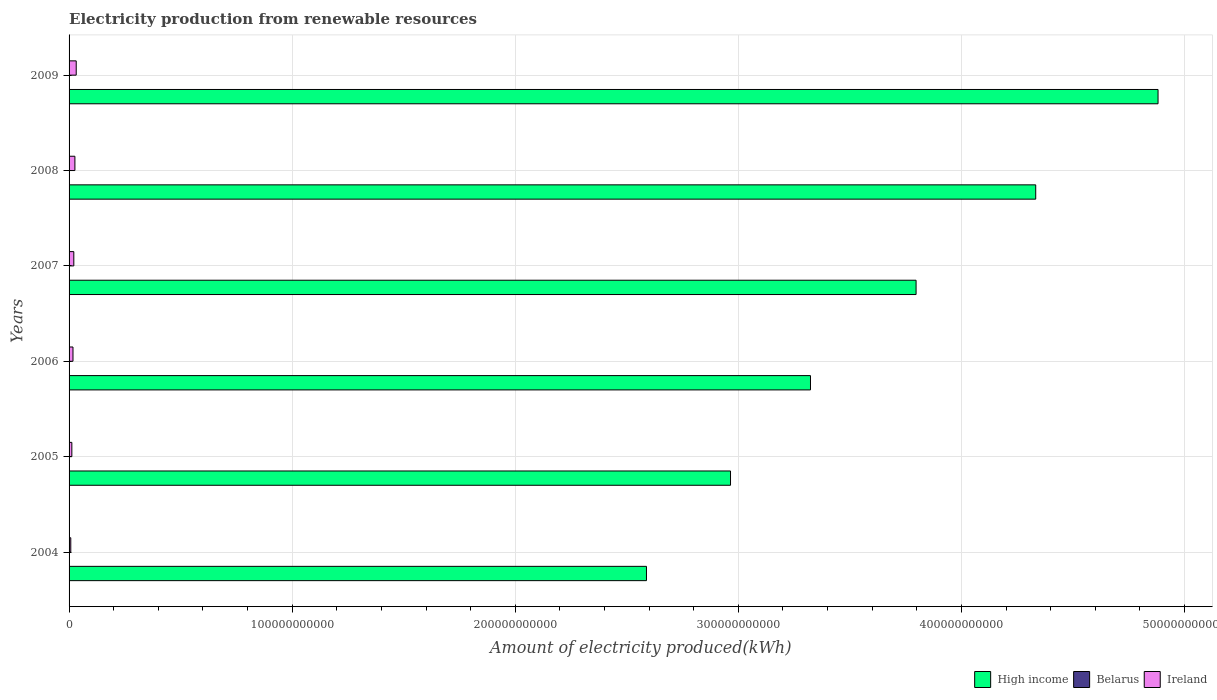How many groups of bars are there?
Your response must be concise. 6. Are the number of bars per tick equal to the number of legend labels?
Keep it short and to the point. Yes. What is the label of the 1st group of bars from the top?
Your answer should be very brief. 2009. What is the amount of electricity produced in High income in 2008?
Provide a succinct answer. 4.33e+11. Across all years, what is the maximum amount of electricity produced in High income?
Your response must be concise. 4.88e+11. Across all years, what is the minimum amount of electricity produced in Ireland?
Offer a terse response. 7.64e+08. What is the total amount of electricity produced in Belarus in the graph?
Your answer should be compact. 1.15e+08. What is the difference between the amount of electricity produced in High income in 2007 and that in 2008?
Make the answer very short. -5.36e+1. What is the difference between the amount of electricity produced in Ireland in 2009 and the amount of electricity produced in Belarus in 2008?
Make the answer very short. 3.17e+09. What is the average amount of electricity produced in Ireland per year?
Your answer should be compact. 1.95e+09. In the year 2005, what is the difference between the amount of electricity produced in Belarus and amount of electricity produced in Ireland?
Your answer should be very brief. -1.24e+09. In how many years, is the amount of electricity produced in Belarus greater than 300000000000 kWh?
Your response must be concise. 0. What is the ratio of the amount of electricity produced in Belarus in 2005 to that in 2006?
Ensure brevity in your answer.  0.33. Is the amount of electricity produced in Belarus in 2005 less than that in 2009?
Keep it short and to the point. Yes. Is the difference between the amount of electricity produced in Belarus in 2007 and 2009 greater than the difference between the amount of electricity produced in Ireland in 2007 and 2009?
Make the answer very short. Yes. What is the difference between the highest and the second highest amount of electricity produced in Belarus?
Your response must be concise. 2.70e+07. What is the difference between the highest and the lowest amount of electricity produced in Ireland?
Offer a very short reply. 2.44e+09. In how many years, is the amount of electricity produced in High income greater than the average amount of electricity produced in High income taken over all years?
Your response must be concise. 3. What does the 2nd bar from the top in 2008 represents?
Ensure brevity in your answer.  Belarus. What does the 2nd bar from the bottom in 2006 represents?
Your answer should be compact. Belarus. Are all the bars in the graph horizontal?
Your response must be concise. Yes. What is the difference between two consecutive major ticks on the X-axis?
Your answer should be very brief. 1.00e+11. Are the values on the major ticks of X-axis written in scientific E-notation?
Provide a succinct answer. No. Does the graph contain any zero values?
Your answer should be very brief. No. Does the graph contain grids?
Your response must be concise. Yes. Where does the legend appear in the graph?
Provide a short and direct response. Bottom right. How many legend labels are there?
Your response must be concise. 3. What is the title of the graph?
Provide a short and direct response. Electricity production from renewable resources. Does "Singapore" appear as one of the legend labels in the graph?
Ensure brevity in your answer.  No. What is the label or title of the X-axis?
Ensure brevity in your answer.  Amount of electricity produced(kWh). What is the Amount of electricity produced(kWh) in High income in 2004?
Your answer should be compact. 2.59e+11. What is the Amount of electricity produced(kWh) of Belarus in 2004?
Your answer should be very brief. 1.00e+06. What is the Amount of electricity produced(kWh) in Ireland in 2004?
Provide a short and direct response. 7.64e+08. What is the Amount of electricity produced(kWh) in High income in 2005?
Keep it short and to the point. 2.97e+11. What is the Amount of electricity produced(kWh) in Belarus in 2005?
Offer a terse response. 1.00e+06. What is the Amount of electricity produced(kWh) of Ireland in 2005?
Provide a short and direct response. 1.24e+09. What is the Amount of electricity produced(kWh) in High income in 2006?
Offer a terse response. 3.32e+11. What is the Amount of electricity produced(kWh) of Ireland in 2006?
Ensure brevity in your answer.  1.75e+09. What is the Amount of electricity produced(kWh) of High income in 2007?
Your answer should be compact. 3.80e+11. What is the Amount of electricity produced(kWh) of Belarus in 2007?
Provide a succinct answer. 1.50e+07. What is the Amount of electricity produced(kWh) of Ireland in 2007?
Offer a terse response. 2.13e+09. What is the Amount of electricity produced(kWh) of High income in 2008?
Offer a very short reply. 4.33e+11. What is the Amount of electricity produced(kWh) of Belarus in 2008?
Provide a short and direct response. 3.40e+07. What is the Amount of electricity produced(kWh) of Ireland in 2008?
Your response must be concise. 2.62e+09. What is the Amount of electricity produced(kWh) of High income in 2009?
Keep it short and to the point. 4.88e+11. What is the Amount of electricity produced(kWh) in Belarus in 2009?
Keep it short and to the point. 6.10e+07. What is the Amount of electricity produced(kWh) of Ireland in 2009?
Provide a short and direct response. 3.21e+09. Across all years, what is the maximum Amount of electricity produced(kWh) of High income?
Provide a short and direct response. 4.88e+11. Across all years, what is the maximum Amount of electricity produced(kWh) of Belarus?
Provide a short and direct response. 6.10e+07. Across all years, what is the maximum Amount of electricity produced(kWh) in Ireland?
Your answer should be very brief. 3.21e+09. Across all years, what is the minimum Amount of electricity produced(kWh) in High income?
Your answer should be very brief. 2.59e+11. Across all years, what is the minimum Amount of electricity produced(kWh) of Ireland?
Your answer should be compact. 7.64e+08. What is the total Amount of electricity produced(kWh) of High income in the graph?
Make the answer very short. 2.19e+12. What is the total Amount of electricity produced(kWh) of Belarus in the graph?
Offer a very short reply. 1.15e+08. What is the total Amount of electricity produced(kWh) in Ireland in the graph?
Offer a terse response. 1.17e+1. What is the difference between the Amount of electricity produced(kWh) of High income in 2004 and that in 2005?
Your answer should be very brief. -3.77e+1. What is the difference between the Amount of electricity produced(kWh) of Ireland in 2004 and that in 2005?
Offer a terse response. -4.78e+08. What is the difference between the Amount of electricity produced(kWh) in High income in 2004 and that in 2006?
Provide a short and direct response. -7.35e+1. What is the difference between the Amount of electricity produced(kWh) of Belarus in 2004 and that in 2006?
Provide a short and direct response. -2.00e+06. What is the difference between the Amount of electricity produced(kWh) of Ireland in 2004 and that in 2006?
Provide a short and direct response. -9.87e+08. What is the difference between the Amount of electricity produced(kWh) of High income in 2004 and that in 2007?
Offer a terse response. -1.21e+11. What is the difference between the Amount of electricity produced(kWh) of Belarus in 2004 and that in 2007?
Your response must be concise. -1.40e+07. What is the difference between the Amount of electricity produced(kWh) of Ireland in 2004 and that in 2007?
Provide a succinct answer. -1.36e+09. What is the difference between the Amount of electricity produced(kWh) in High income in 2004 and that in 2008?
Provide a succinct answer. -1.74e+11. What is the difference between the Amount of electricity produced(kWh) in Belarus in 2004 and that in 2008?
Ensure brevity in your answer.  -3.30e+07. What is the difference between the Amount of electricity produced(kWh) in Ireland in 2004 and that in 2008?
Make the answer very short. -1.86e+09. What is the difference between the Amount of electricity produced(kWh) in High income in 2004 and that in 2009?
Your answer should be compact. -2.29e+11. What is the difference between the Amount of electricity produced(kWh) of Belarus in 2004 and that in 2009?
Provide a short and direct response. -6.00e+07. What is the difference between the Amount of electricity produced(kWh) of Ireland in 2004 and that in 2009?
Make the answer very short. -2.44e+09. What is the difference between the Amount of electricity produced(kWh) in High income in 2005 and that in 2006?
Offer a terse response. -3.59e+1. What is the difference between the Amount of electricity produced(kWh) of Belarus in 2005 and that in 2006?
Offer a very short reply. -2.00e+06. What is the difference between the Amount of electricity produced(kWh) of Ireland in 2005 and that in 2006?
Keep it short and to the point. -5.09e+08. What is the difference between the Amount of electricity produced(kWh) of High income in 2005 and that in 2007?
Keep it short and to the point. -8.32e+1. What is the difference between the Amount of electricity produced(kWh) in Belarus in 2005 and that in 2007?
Offer a very short reply. -1.40e+07. What is the difference between the Amount of electricity produced(kWh) of Ireland in 2005 and that in 2007?
Ensure brevity in your answer.  -8.85e+08. What is the difference between the Amount of electricity produced(kWh) of High income in 2005 and that in 2008?
Your response must be concise. -1.37e+11. What is the difference between the Amount of electricity produced(kWh) in Belarus in 2005 and that in 2008?
Keep it short and to the point. -3.30e+07. What is the difference between the Amount of electricity produced(kWh) in Ireland in 2005 and that in 2008?
Ensure brevity in your answer.  -1.38e+09. What is the difference between the Amount of electricity produced(kWh) of High income in 2005 and that in 2009?
Offer a terse response. -1.92e+11. What is the difference between the Amount of electricity produced(kWh) in Belarus in 2005 and that in 2009?
Give a very brief answer. -6.00e+07. What is the difference between the Amount of electricity produced(kWh) of Ireland in 2005 and that in 2009?
Your answer should be very brief. -1.96e+09. What is the difference between the Amount of electricity produced(kWh) of High income in 2006 and that in 2007?
Keep it short and to the point. -4.73e+1. What is the difference between the Amount of electricity produced(kWh) in Belarus in 2006 and that in 2007?
Provide a short and direct response. -1.20e+07. What is the difference between the Amount of electricity produced(kWh) in Ireland in 2006 and that in 2007?
Make the answer very short. -3.76e+08. What is the difference between the Amount of electricity produced(kWh) in High income in 2006 and that in 2008?
Provide a succinct answer. -1.01e+11. What is the difference between the Amount of electricity produced(kWh) in Belarus in 2006 and that in 2008?
Provide a succinct answer. -3.10e+07. What is the difference between the Amount of electricity produced(kWh) in Ireland in 2006 and that in 2008?
Provide a succinct answer. -8.68e+08. What is the difference between the Amount of electricity produced(kWh) of High income in 2006 and that in 2009?
Your answer should be very brief. -1.56e+11. What is the difference between the Amount of electricity produced(kWh) of Belarus in 2006 and that in 2009?
Keep it short and to the point. -5.80e+07. What is the difference between the Amount of electricity produced(kWh) in Ireland in 2006 and that in 2009?
Provide a short and direct response. -1.46e+09. What is the difference between the Amount of electricity produced(kWh) of High income in 2007 and that in 2008?
Your answer should be compact. -5.36e+1. What is the difference between the Amount of electricity produced(kWh) of Belarus in 2007 and that in 2008?
Offer a terse response. -1.90e+07. What is the difference between the Amount of electricity produced(kWh) in Ireland in 2007 and that in 2008?
Provide a succinct answer. -4.92e+08. What is the difference between the Amount of electricity produced(kWh) in High income in 2007 and that in 2009?
Offer a very short reply. -1.08e+11. What is the difference between the Amount of electricity produced(kWh) in Belarus in 2007 and that in 2009?
Your answer should be compact. -4.60e+07. What is the difference between the Amount of electricity produced(kWh) in Ireland in 2007 and that in 2009?
Your answer should be very brief. -1.08e+09. What is the difference between the Amount of electricity produced(kWh) in High income in 2008 and that in 2009?
Your answer should be compact. -5.48e+1. What is the difference between the Amount of electricity produced(kWh) in Belarus in 2008 and that in 2009?
Your answer should be very brief. -2.70e+07. What is the difference between the Amount of electricity produced(kWh) in Ireland in 2008 and that in 2009?
Give a very brief answer. -5.87e+08. What is the difference between the Amount of electricity produced(kWh) of High income in 2004 and the Amount of electricity produced(kWh) of Belarus in 2005?
Make the answer very short. 2.59e+11. What is the difference between the Amount of electricity produced(kWh) of High income in 2004 and the Amount of electricity produced(kWh) of Ireland in 2005?
Ensure brevity in your answer.  2.58e+11. What is the difference between the Amount of electricity produced(kWh) of Belarus in 2004 and the Amount of electricity produced(kWh) of Ireland in 2005?
Make the answer very short. -1.24e+09. What is the difference between the Amount of electricity produced(kWh) in High income in 2004 and the Amount of electricity produced(kWh) in Belarus in 2006?
Provide a short and direct response. 2.59e+11. What is the difference between the Amount of electricity produced(kWh) in High income in 2004 and the Amount of electricity produced(kWh) in Ireland in 2006?
Provide a succinct answer. 2.57e+11. What is the difference between the Amount of electricity produced(kWh) of Belarus in 2004 and the Amount of electricity produced(kWh) of Ireland in 2006?
Offer a very short reply. -1.75e+09. What is the difference between the Amount of electricity produced(kWh) of High income in 2004 and the Amount of electricity produced(kWh) of Belarus in 2007?
Provide a short and direct response. 2.59e+11. What is the difference between the Amount of electricity produced(kWh) of High income in 2004 and the Amount of electricity produced(kWh) of Ireland in 2007?
Ensure brevity in your answer.  2.57e+11. What is the difference between the Amount of electricity produced(kWh) in Belarus in 2004 and the Amount of electricity produced(kWh) in Ireland in 2007?
Your response must be concise. -2.13e+09. What is the difference between the Amount of electricity produced(kWh) of High income in 2004 and the Amount of electricity produced(kWh) of Belarus in 2008?
Provide a short and direct response. 2.59e+11. What is the difference between the Amount of electricity produced(kWh) of High income in 2004 and the Amount of electricity produced(kWh) of Ireland in 2008?
Give a very brief answer. 2.56e+11. What is the difference between the Amount of electricity produced(kWh) in Belarus in 2004 and the Amount of electricity produced(kWh) in Ireland in 2008?
Provide a succinct answer. -2.62e+09. What is the difference between the Amount of electricity produced(kWh) in High income in 2004 and the Amount of electricity produced(kWh) in Belarus in 2009?
Keep it short and to the point. 2.59e+11. What is the difference between the Amount of electricity produced(kWh) in High income in 2004 and the Amount of electricity produced(kWh) in Ireland in 2009?
Give a very brief answer. 2.56e+11. What is the difference between the Amount of electricity produced(kWh) in Belarus in 2004 and the Amount of electricity produced(kWh) in Ireland in 2009?
Provide a short and direct response. -3.20e+09. What is the difference between the Amount of electricity produced(kWh) of High income in 2005 and the Amount of electricity produced(kWh) of Belarus in 2006?
Your answer should be very brief. 2.97e+11. What is the difference between the Amount of electricity produced(kWh) of High income in 2005 and the Amount of electricity produced(kWh) of Ireland in 2006?
Your response must be concise. 2.95e+11. What is the difference between the Amount of electricity produced(kWh) in Belarus in 2005 and the Amount of electricity produced(kWh) in Ireland in 2006?
Give a very brief answer. -1.75e+09. What is the difference between the Amount of electricity produced(kWh) of High income in 2005 and the Amount of electricity produced(kWh) of Belarus in 2007?
Keep it short and to the point. 2.96e+11. What is the difference between the Amount of electricity produced(kWh) in High income in 2005 and the Amount of electricity produced(kWh) in Ireland in 2007?
Your answer should be very brief. 2.94e+11. What is the difference between the Amount of electricity produced(kWh) of Belarus in 2005 and the Amount of electricity produced(kWh) of Ireland in 2007?
Offer a terse response. -2.13e+09. What is the difference between the Amount of electricity produced(kWh) in High income in 2005 and the Amount of electricity produced(kWh) in Belarus in 2008?
Your response must be concise. 2.96e+11. What is the difference between the Amount of electricity produced(kWh) of High income in 2005 and the Amount of electricity produced(kWh) of Ireland in 2008?
Your answer should be compact. 2.94e+11. What is the difference between the Amount of electricity produced(kWh) in Belarus in 2005 and the Amount of electricity produced(kWh) in Ireland in 2008?
Make the answer very short. -2.62e+09. What is the difference between the Amount of electricity produced(kWh) in High income in 2005 and the Amount of electricity produced(kWh) in Belarus in 2009?
Provide a succinct answer. 2.96e+11. What is the difference between the Amount of electricity produced(kWh) in High income in 2005 and the Amount of electricity produced(kWh) in Ireland in 2009?
Keep it short and to the point. 2.93e+11. What is the difference between the Amount of electricity produced(kWh) in Belarus in 2005 and the Amount of electricity produced(kWh) in Ireland in 2009?
Provide a succinct answer. -3.20e+09. What is the difference between the Amount of electricity produced(kWh) in High income in 2006 and the Amount of electricity produced(kWh) in Belarus in 2007?
Provide a short and direct response. 3.32e+11. What is the difference between the Amount of electricity produced(kWh) of High income in 2006 and the Amount of electricity produced(kWh) of Ireland in 2007?
Your response must be concise. 3.30e+11. What is the difference between the Amount of electricity produced(kWh) in Belarus in 2006 and the Amount of electricity produced(kWh) in Ireland in 2007?
Your answer should be compact. -2.12e+09. What is the difference between the Amount of electricity produced(kWh) of High income in 2006 and the Amount of electricity produced(kWh) of Belarus in 2008?
Ensure brevity in your answer.  3.32e+11. What is the difference between the Amount of electricity produced(kWh) of High income in 2006 and the Amount of electricity produced(kWh) of Ireland in 2008?
Give a very brief answer. 3.30e+11. What is the difference between the Amount of electricity produced(kWh) in Belarus in 2006 and the Amount of electricity produced(kWh) in Ireland in 2008?
Provide a short and direct response. -2.62e+09. What is the difference between the Amount of electricity produced(kWh) in High income in 2006 and the Amount of electricity produced(kWh) in Belarus in 2009?
Provide a short and direct response. 3.32e+11. What is the difference between the Amount of electricity produced(kWh) of High income in 2006 and the Amount of electricity produced(kWh) of Ireland in 2009?
Your response must be concise. 3.29e+11. What is the difference between the Amount of electricity produced(kWh) of Belarus in 2006 and the Amount of electricity produced(kWh) of Ireland in 2009?
Your answer should be very brief. -3.20e+09. What is the difference between the Amount of electricity produced(kWh) of High income in 2007 and the Amount of electricity produced(kWh) of Belarus in 2008?
Your answer should be compact. 3.80e+11. What is the difference between the Amount of electricity produced(kWh) in High income in 2007 and the Amount of electricity produced(kWh) in Ireland in 2008?
Your answer should be very brief. 3.77e+11. What is the difference between the Amount of electricity produced(kWh) in Belarus in 2007 and the Amount of electricity produced(kWh) in Ireland in 2008?
Your answer should be very brief. -2.60e+09. What is the difference between the Amount of electricity produced(kWh) of High income in 2007 and the Amount of electricity produced(kWh) of Belarus in 2009?
Your response must be concise. 3.80e+11. What is the difference between the Amount of electricity produced(kWh) in High income in 2007 and the Amount of electricity produced(kWh) in Ireland in 2009?
Your answer should be very brief. 3.76e+11. What is the difference between the Amount of electricity produced(kWh) of Belarus in 2007 and the Amount of electricity produced(kWh) of Ireland in 2009?
Offer a very short reply. -3.19e+09. What is the difference between the Amount of electricity produced(kWh) in High income in 2008 and the Amount of electricity produced(kWh) in Belarus in 2009?
Give a very brief answer. 4.33e+11. What is the difference between the Amount of electricity produced(kWh) of High income in 2008 and the Amount of electricity produced(kWh) of Ireland in 2009?
Make the answer very short. 4.30e+11. What is the difference between the Amount of electricity produced(kWh) in Belarus in 2008 and the Amount of electricity produced(kWh) in Ireland in 2009?
Make the answer very short. -3.17e+09. What is the average Amount of electricity produced(kWh) of High income per year?
Provide a short and direct response. 3.65e+11. What is the average Amount of electricity produced(kWh) of Belarus per year?
Your response must be concise. 1.92e+07. What is the average Amount of electricity produced(kWh) of Ireland per year?
Your answer should be very brief. 1.95e+09. In the year 2004, what is the difference between the Amount of electricity produced(kWh) in High income and Amount of electricity produced(kWh) in Belarus?
Your answer should be compact. 2.59e+11. In the year 2004, what is the difference between the Amount of electricity produced(kWh) of High income and Amount of electricity produced(kWh) of Ireland?
Your answer should be compact. 2.58e+11. In the year 2004, what is the difference between the Amount of electricity produced(kWh) in Belarus and Amount of electricity produced(kWh) in Ireland?
Give a very brief answer. -7.63e+08. In the year 2005, what is the difference between the Amount of electricity produced(kWh) of High income and Amount of electricity produced(kWh) of Belarus?
Offer a very short reply. 2.97e+11. In the year 2005, what is the difference between the Amount of electricity produced(kWh) in High income and Amount of electricity produced(kWh) in Ireland?
Make the answer very short. 2.95e+11. In the year 2005, what is the difference between the Amount of electricity produced(kWh) in Belarus and Amount of electricity produced(kWh) in Ireland?
Make the answer very short. -1.24e+09. In the year 2006, what is the difference between the Amount of electricity produced(kWh) in High income and Amount of electricity produced(kWh) in Belarus?
Offer a very short reply. 3.32e+11. In the year 2006, what is the difference between the Amount of electricity produced(kWh) in High income and Amount of electricity produced(kWh) in Ireland?
Provide a succinct answer. 3.31e+11. In the year 2006, what is the difference between the Amount of electricity produced(kWh) in Belarus and Amount of electricity produced(kWh) in Ireland?
Provide a succinct answer. -1.75e+09. In the year 2007, what is the difference between the Amount of electricity produced(kWh) of High income and Amount of electricity produced(kWh) of Belarus?
Provide a succinct answer. 3.80e+11. In the year 2007, what is the difference between the Amount of electricity produced(kWh) in High income and Amount of electricity produced(kWh) in Ireland?
Your answer should be very brief. 3.78e+11. In the year 2007, what is the difference between the Amount of electricity produced(kWh) in Belarus and Amount of electricity produced(kWh) in Ireland?
Keep it short and to the point. -2.11e+09. In the year 2008, what is the difference between the Amount of electricity produced(kWh) of High income and Amount of electricity produced(kWh) of Belarus?
Keep it short and to the point. 4.33e+11. In the year 2008, what is the difference between the Amount of electricity produced(kWh) of High income and Amount of electricity produced(kWh) of Ireland?
Offer a very short reply. 4.31e+11. In the year 2008, what is the difference between the Amount of electricity produced(kWh) of Belarus and Amount of electricity produced(kWh) of Ireland?
Provide a succinct answer. -2.58e+09. In the year 2009, what is the difference between the Amount of electricity produced(kWh) in High income and Amount of electricity produced(kWh) in Belarus?
Your answer should be compact. 4.88e+11. In the year 2009, what is the difference between the Amount of electricity produced(kWh) of High income and Amount of electricity produced(kWh) of Ireland?
Ensure brevity in your answer.  4.85e+11. In the year 2009, what is the difference between the Amount of electricity produced(kWh) of Belarus and Amount of electricity produced(kWh) of Ireland?
Provide a succinct answer. -3.14e+09. What is the ratio of the Amount of electricity produced(kWh) in High income in 2004 to that in 2005?
Provide a short and direct response. 0.87. What is the ratio of the Amount of electricity produced(kWh) of Belarus in 2004 to that in 2005?
Give a very brief answer. 1. What is the ratio of the Amount of electricity produced(kWh) in Ireland in 2004 to that in 2005?
Give a very brief answer. 0.62. What is the ratio of the Amount of electricity produced(kWh) of High income in 2004 to that in 2006?
Offer a very short reply. 0.78. What is the ratio of the Amount of electricity produced(kWh) in Ireland in 2004 to that in 2006?
Your response must be concise. 0.44. What is the ratio of the Amount of electricity produced(kWh) in High income in 2004 to that in 2007?
Offer a terse response. 0.68. What is the ratio of the Amount of electricity produced(kWh) of Belarus in 2004 to that in 2007?
Provide a succinct answer. 0.07. What is the ratio of the Amount of electricity produced(kWh) in Ireland in 2004 to that in 2007?
Provide a short and direct response. 0.36. What is the ratio of the Amount of electricity produced(kWh) in High income in 2004 to that in 2008?
Give a very brief answer. 0.6. What is the ratio of the Amount of electricity produced(kWh) of Belarus in 2004 to that in 2008?
Ensure brevity in your answer.  0.03. What is the ratio of the Amount of electricity produced(kWh) in Ireland in 2004 to that in 2008?
Make the answer very short. 0.29. What is the ratio of the Amount of electricity produced(kWh) in High income in 2004 to that in 2009?
Give a very brief answer. 0.53. What is the ratio of the Amount of electricity produced(kWh) of Belarus in 2004 to that in 2009?
Provide a succinct answer. 0.02. What is the ratio of the Amount of electricity produced(kWh) of Ireland in 2004 to that in 2009?
Offer a terse response. 0.24. What is the ratio of the Amount of electricity produced(kWh) in High income in 2005 to that in 2006?
Your answer should be compact. 0.89. What is the ratio of the Amount of electricity produced(kWh) in Belarus in 2005 to that in 2006?
Offer a very short reply. 0.33. What is the ratio of the Amount of electricity produced(kWh) of Ireland in 2005 to that in 2006?
Offer a very short reply. 0.71. What is the ratio of the Amount of electricity produced(kWh) in High income in 2005 to that in 2007?
Provide a short and direct response. 0.78. What is the ratio of the Amount of electricity produced(kWh) of Belarus in 2005 to that in 2007?
Ensure brevity in your answer.  0.07. What is the ratio of the Amount of electricity produced(kWh) of Ireland in 2005 to that in 2007?
Keep it short and to the point. 0.58. What is the ratio of the Amount of electricity produced(kWh) of High income in 2005 to that in 2008?
Ensure brevity in your answer.  0.68. What is the ratio of the Amount of electricity produced(kWh) of Belarus in 2005 to that in 2008?
Offer a terse response. 0.03. What is the ratio of the Amount of electricity produced(kWh) in Ireland in 2005 to that in 2008?
Make the answer very short. 0.47. What is the ratio of the Amount of electricity produced(kWh) in High income in 2005 to that in 2009?
Make the answer very short. 0.61. What is the ratio of the Amount of electricity produced(kWh) of Belarus in 2005 to that in 2009?
Offer a terse response. 0.02. What is the ratio of the Amount of electricity produced(kWh) in Ireland in 2005 to that in 2009?
Make the answer very short. 0.39. What is the ratio of the Amount of electricity produced(kWh) of High income in 2006 to that in 2007?
Offer a terse response. 0.88. What is the ratio of the Amount of electricity produced(kWh) of Ireland in 2006 to that in 2007?
Keep it short and to the point. 0.82. What is the ratio of the Amount of electricity produced(kWh) of High income in 2006 to that in 2008?
Keep it short and to the point. 0.77. What is the ratio of the Amount of electricity produced(kWh) in Belarus in 2006 to that in 2008?
Make the answer very short. 0.09. What is the ratio of the Amount of electricity produced(kWh) of Ireland in 2006 to that in 2008?
Provide a succinct answer. 0.67. What is the ratio of the Amount of electricity produced(kWh) of High income in 2006 to that in 2009?
Your answer should be very brief. 0.68. What is the ratio of the Amount of electricity produced(kWh) of Belarus in 2006 to that in 2009?
Keep it short and to the point. 0.05. What is the ratio of the Amount of electricity produced(kWh) of Ireland in 2006 to that in 2009?
Provide a succinct answer. 0.55. What is the ratio of the Amount of electricity produced(kWh) in High income in 2007 to that in 2008?
Keep it short and to the point. 0.88. What is the ratio of the Amount of electricity produced(kWh) of Belarus in 2007 to that in 2008?
Ensure brevity in your answer.  0.44. What is the ratio of the Amount of electricity produced(kWh) of Ireland in 2007 to that in 2008?
Your answer should be very brief. 0.81. What is the ratio of the Amount of electricity produced(kWh) in Belarus in 2007 to that in 2009?
Offer a terse response. 0.25. What is the ratio of the Amount of electricity produced(kWh) in Ireland in 2007 to that in 2009?
Keep it short and to the point. 0.66. What is the ratio of the Amount of electricity produced(kWh) of High income in 2008 to that in 2009?
Your response must be concise. 0.89. What is the ratio of the Amount of electricity produced(kWh) of Belarus in 2008 to that in 2009?
Ensure brevity in your answer.  0.56. What is the ratio of the Amount of electricity produced(kWh) of Ireland in 2008 to that in 2009?
Your answer should be very brief. 0.82. What is the difference between the highest and the second highest Amount of electricity produced(kWh) in High income?
Provide a succinct answer. 5.48e+1. What is the difference between the highest and the second highest Amount of electricity produced(kWh) in Belarus?
Offer a very short reply. 2.70e+07. What is the difference between the highest and the second highest Amount of electricity produced(kWh) of Ireland?
Give a very brief answer. 5.87e+08. What is the difference between the highest and the lowest Amount of electricity produced(kWh) in High income?
Make the answer very short. 2.29e+11. What is the difference between the highest and the lowest Amount of electricity produced(kWh) in Belarus?
Your answer should be very brief. 6.00e+07. What is the difference between the highest and the lowest Amount of electricity produced(kWh) in Ireland?
Your answer should be compact. 2.44e+09. 